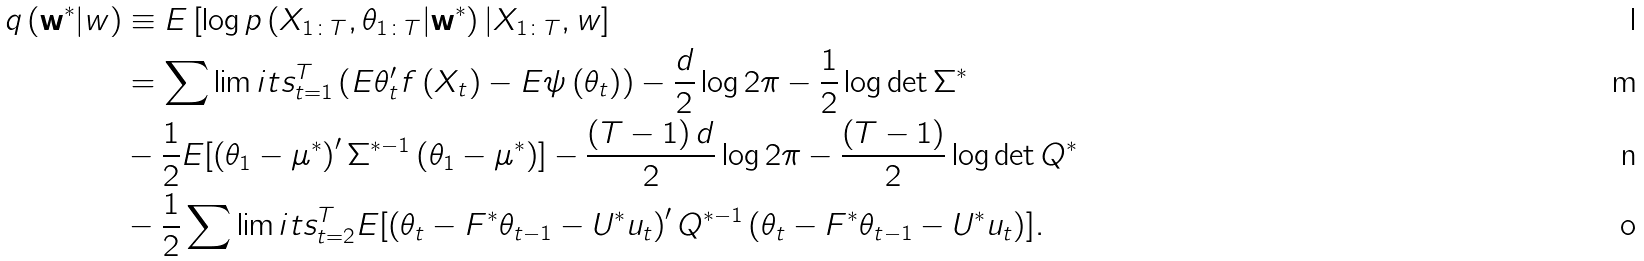<formula> <loc_0><loc_0><loc_500><loc_500>q \left ( \mathbf { w } ^ { \ast } | w \right ) & \equiv E \left [ \log p \left ( X _ { 1 \colon T } , \theta _ { 1 \colon T } | \mathbf { w } ^ { \ast } \right ) | X _ { 1 \colon T } , w \right ] \\ & = \sum \lim i t s _ { t = 1 } ^ { T } \left ( E \theta ^ { \prime } _ { t } f \left ( X _ { t } \right ) - E \psi \left ( \theta _ { t } \right ) \right ) - \frac { d } { 2 } \log { 2 \pi } - \frac { 1 } { 2 } \log { \det \Sigma ^ { \ast } } \\ & - \frac { 1 } { 2 } E [ \left ( \theta _ { 1 } - \mu ^ { \ast } \right ) ^ { \prime } \Sigma ^ { \ast - 1 } \left ( \theta _ { 1 } - \mu ^ { \ast } \right ) ] - \frac { \left ( T - 1 \right ) d } { 2 } \log { 2 \pi } - \frac { \left ( T - 1 \right ) } { 2 } \log { \det Q ^ { \ast } } \\ & - \frac { 1 } { 2 } \sum \lim i t s _ { t = 2 } ^ { T } E [ \left ( \theta _ { t } - F ^ { \ast } \theta _ { t - 1 } - U ^ { \ast } u _ { t } \right ) ^ { \prime } Q ^ { \ast - 1 } \left ( \theta _ { t } - F ^ { \ast } \theta _ { t - 1 } - U ^ { \ast } u _ { t } \right ) ] .</formula> 